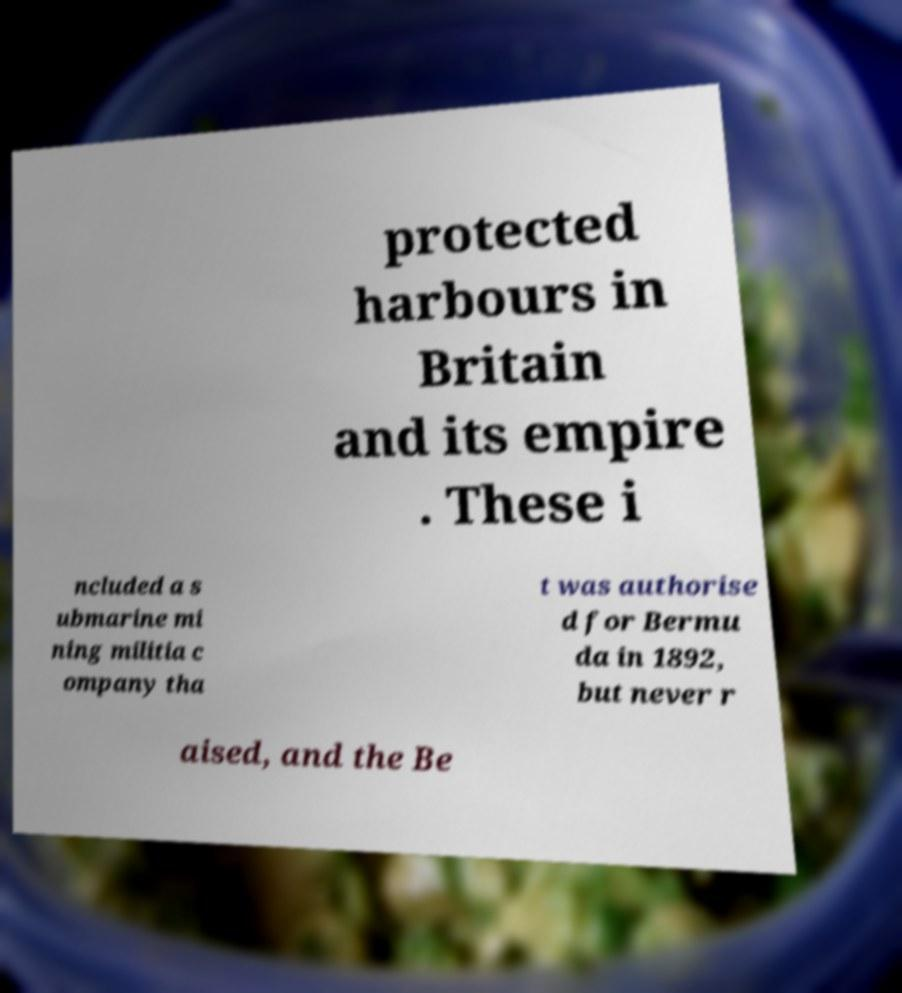For documentation purposes, I need the text within this image transcribed. Could you provide that? protected harbours in Britain and its empire . These i ncluded a s ubmarine mi ning militia c ompany tha t was authorise d for Bermu da in 1892, but never r aised, and the Be 